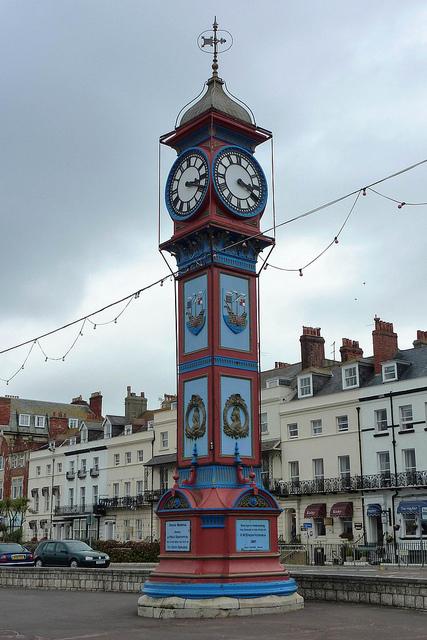What time is it?
Answer briefly. 3:20. What colors are the clock tower?
Be succinct. Red and blue. What are the buildings made of?
Write a very short answer. Brick. Are there birds on the clock?
Quick response, please. No. How many windows are in the buildings behind the Clock Tower?
Answer briefly. 35. Is this a large city?
Answer briefly. Yes. What time does the large clock say it is?
Concise answer only. 3:20. 